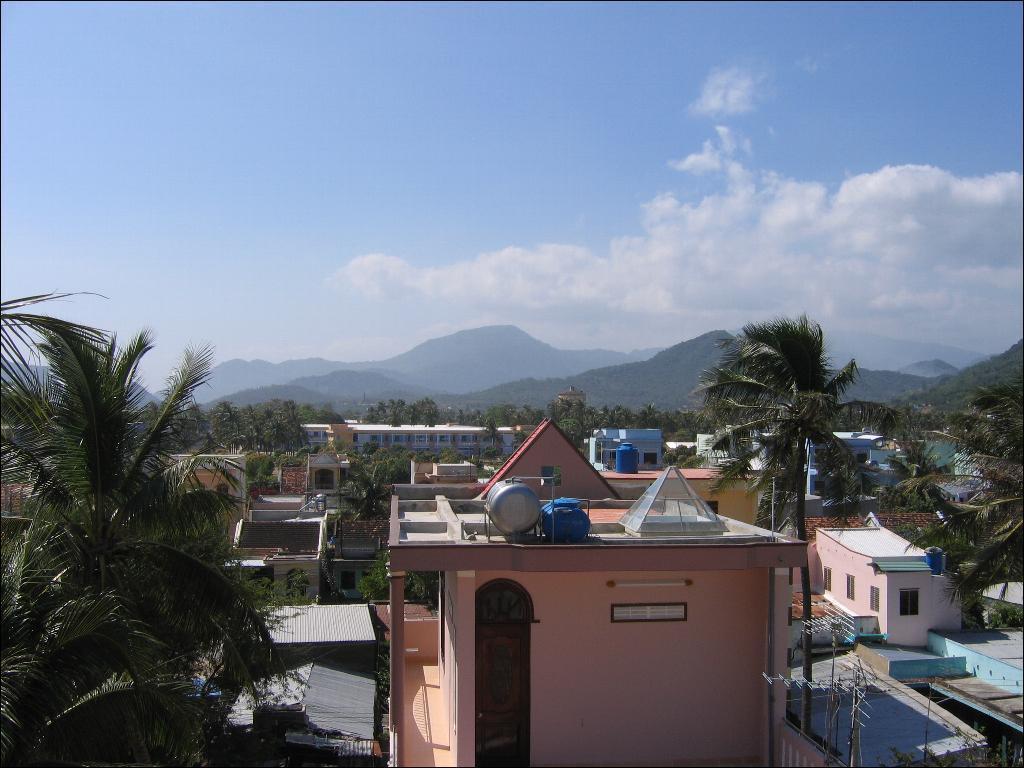Could you give a brief overview of what you see in this image? This image is taken outdoors. At the top of the image there is the sky with clouds. In the background there are a few hills. In the middle of the image there are many houses and buildings with walls, windows, doors and roofs. There are many trees with leaves, stems and branches. 